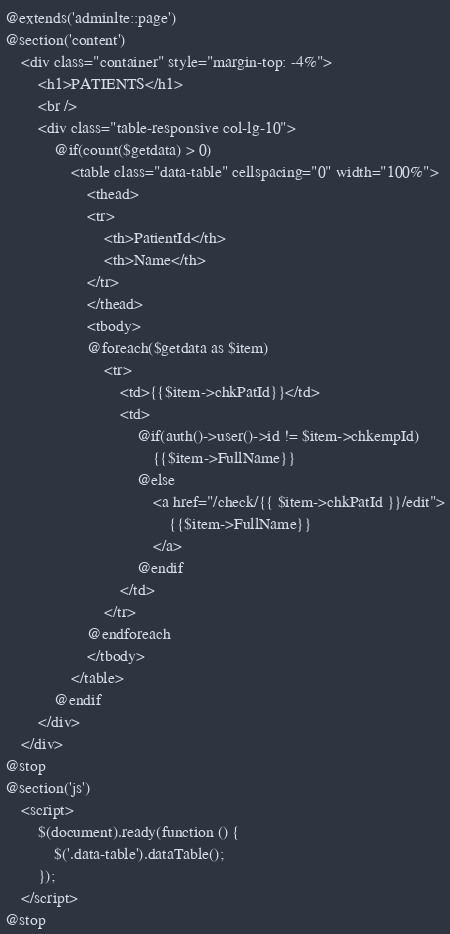<code> <loc_0><loc_0><loc_500><loc_500><_PHP_>@extends('adminlte::page')
@section('content')
    <div class="container" style="margin-top: -4%">
        <h1>PATIENTS</h1>
        <br />
        <div class="table-responsive col-lg-10">
            @if(count($getdata) > 0)
                <table class="data-table" cellspacing="0" width="100%">
                    <thead>
                    <tr>
                        <th>PatientId</th>
                        <th>Name</th>
                    </tr>
                    </thead>
                    <tbody>
                    @foreach($getdata as $item)
                        <tr>
                            <td>{{$item->chkPatId}}</td>
                            <td>
                                @if(auth()->user()->id != $item->chkempId)
                                    {{$item->FullName}}
                                @else
                                    <a href="/check/{{ $item->chkPatId }}/edit">
                                        {{$item->FullName}}
                                    </a>
                                @endif
                            </td>
                        </tr>
                    @endforeach
                    </tbody>
                </table>
            @endif
        </div>
    </div>
@stop
@section('js')
    <script>
        $(document).ready(function () {
            $('.data-table').dataTable();
        });
    </script>
@stop</code> 